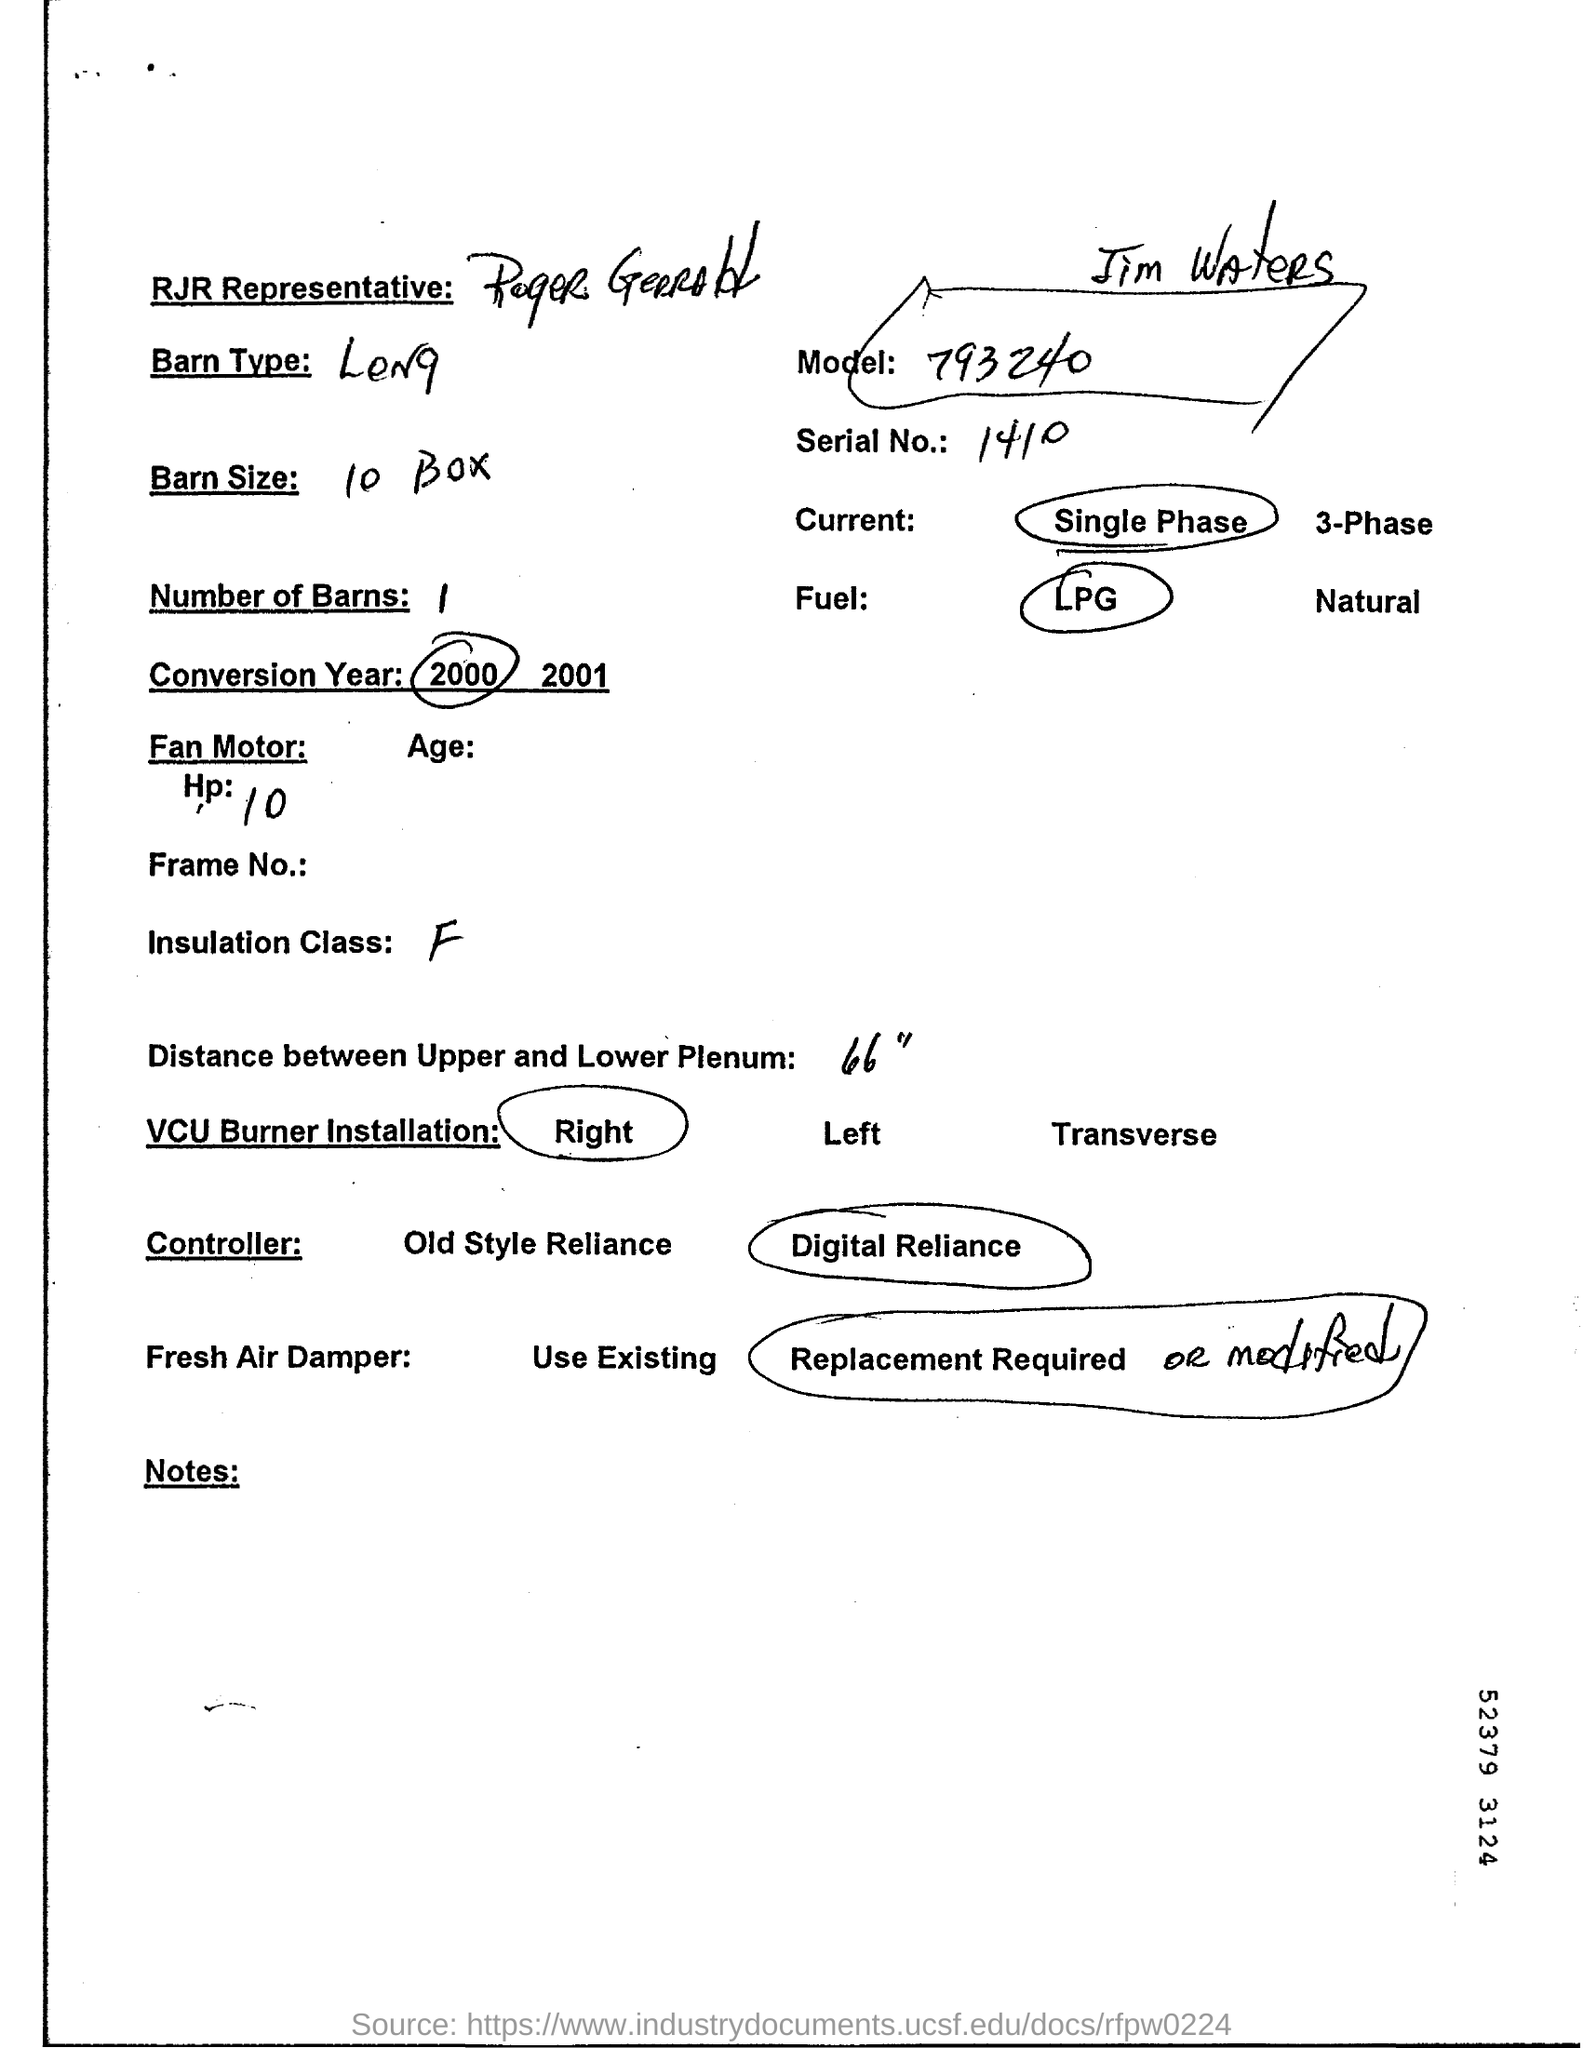Identify some key points in this picture. The size of the barn is 10 Boxes. The serial number is 1410. The distance between the upper and lower plenum is 66 feet. The model number is 793240... 